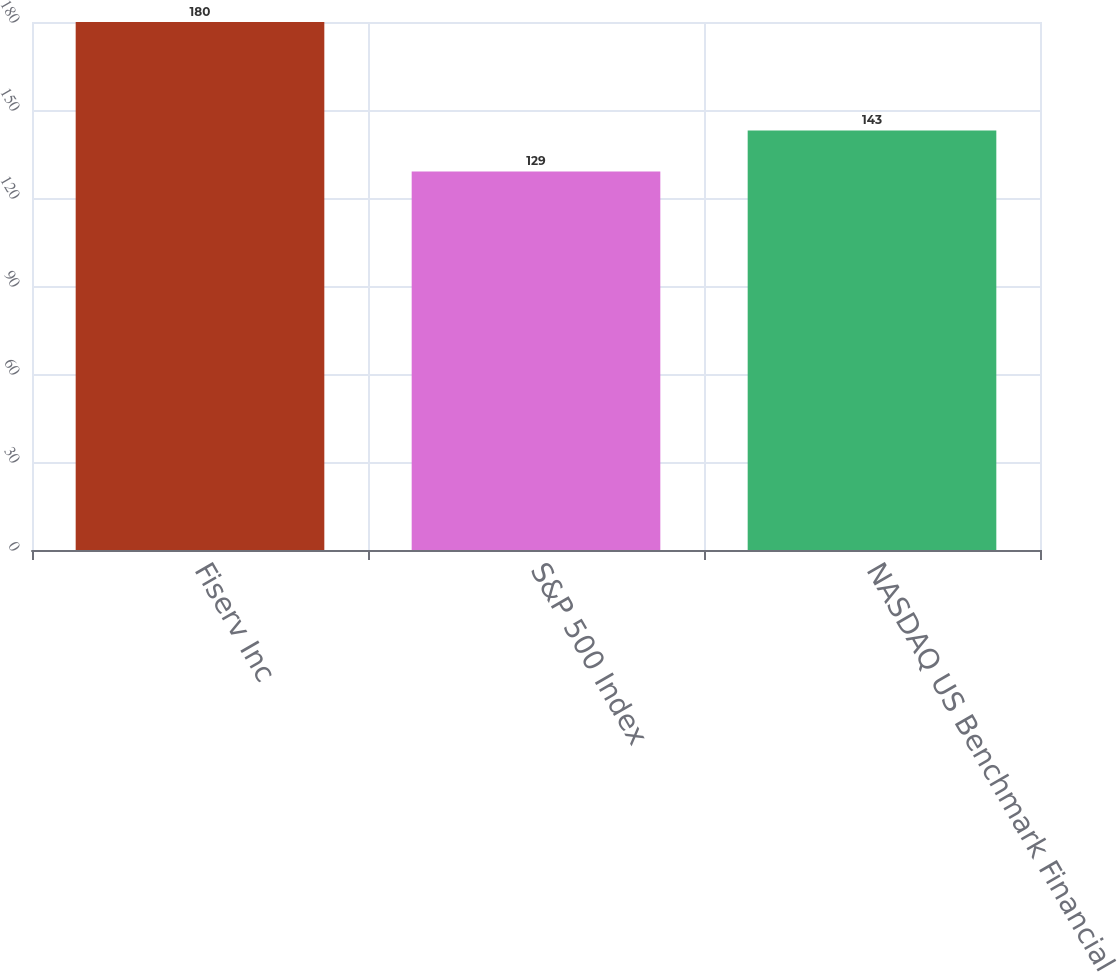Convert chart to OTSL. <chart><loc_0><loc_0><loc_500><loc_500><bar_chart><fcel>Fiserv Inc<fcel>S&P 500 Index<fcel>NASDAQ US Benchmark Financial<nl><fcel>180<fcel>129<fcel>143<nl></chart> 